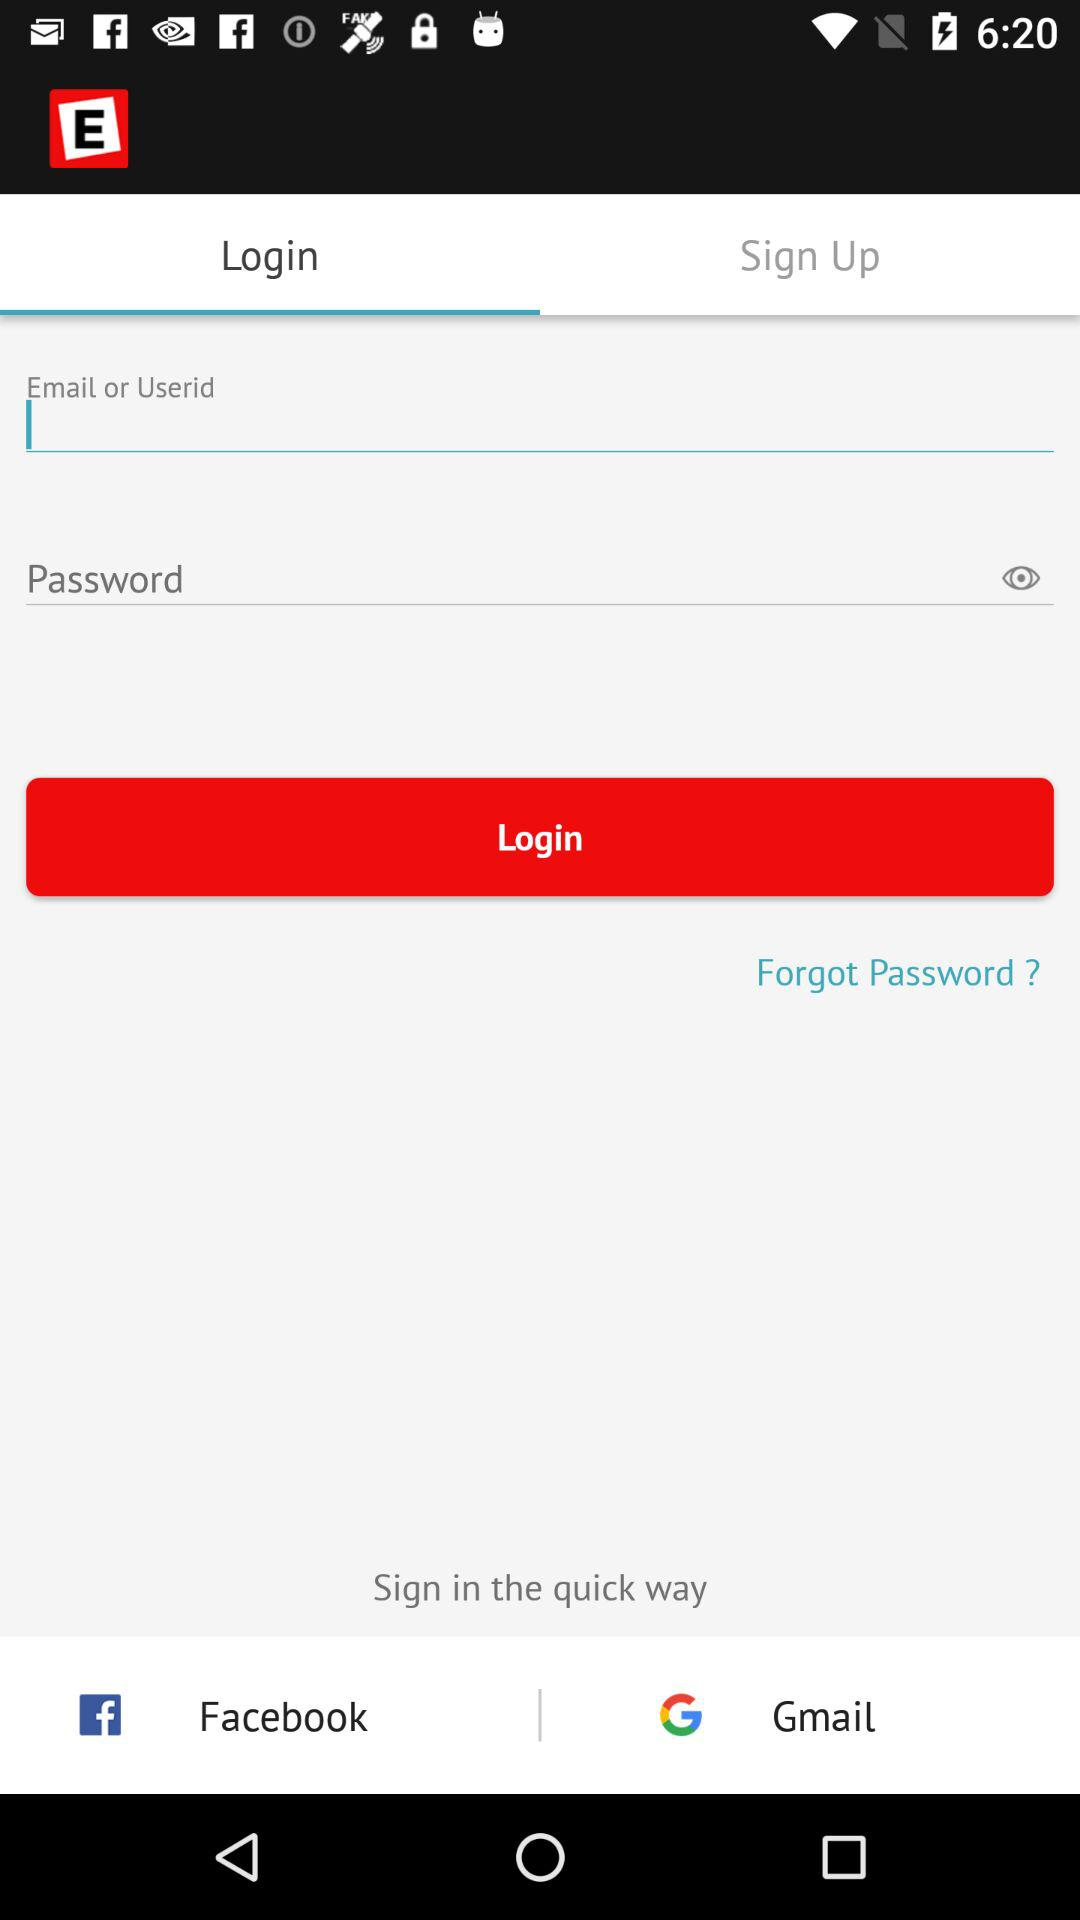Which tab am I using? You are using the "Login" tab. 